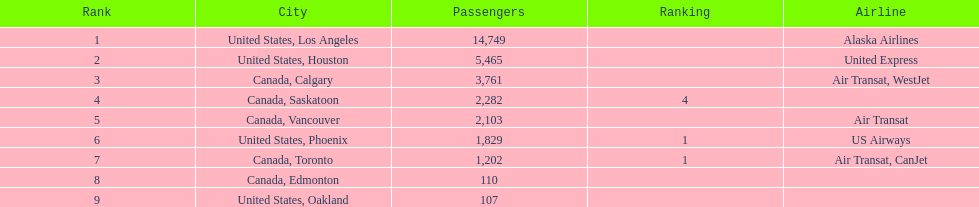How many cities on this list belong to canada? 5. 